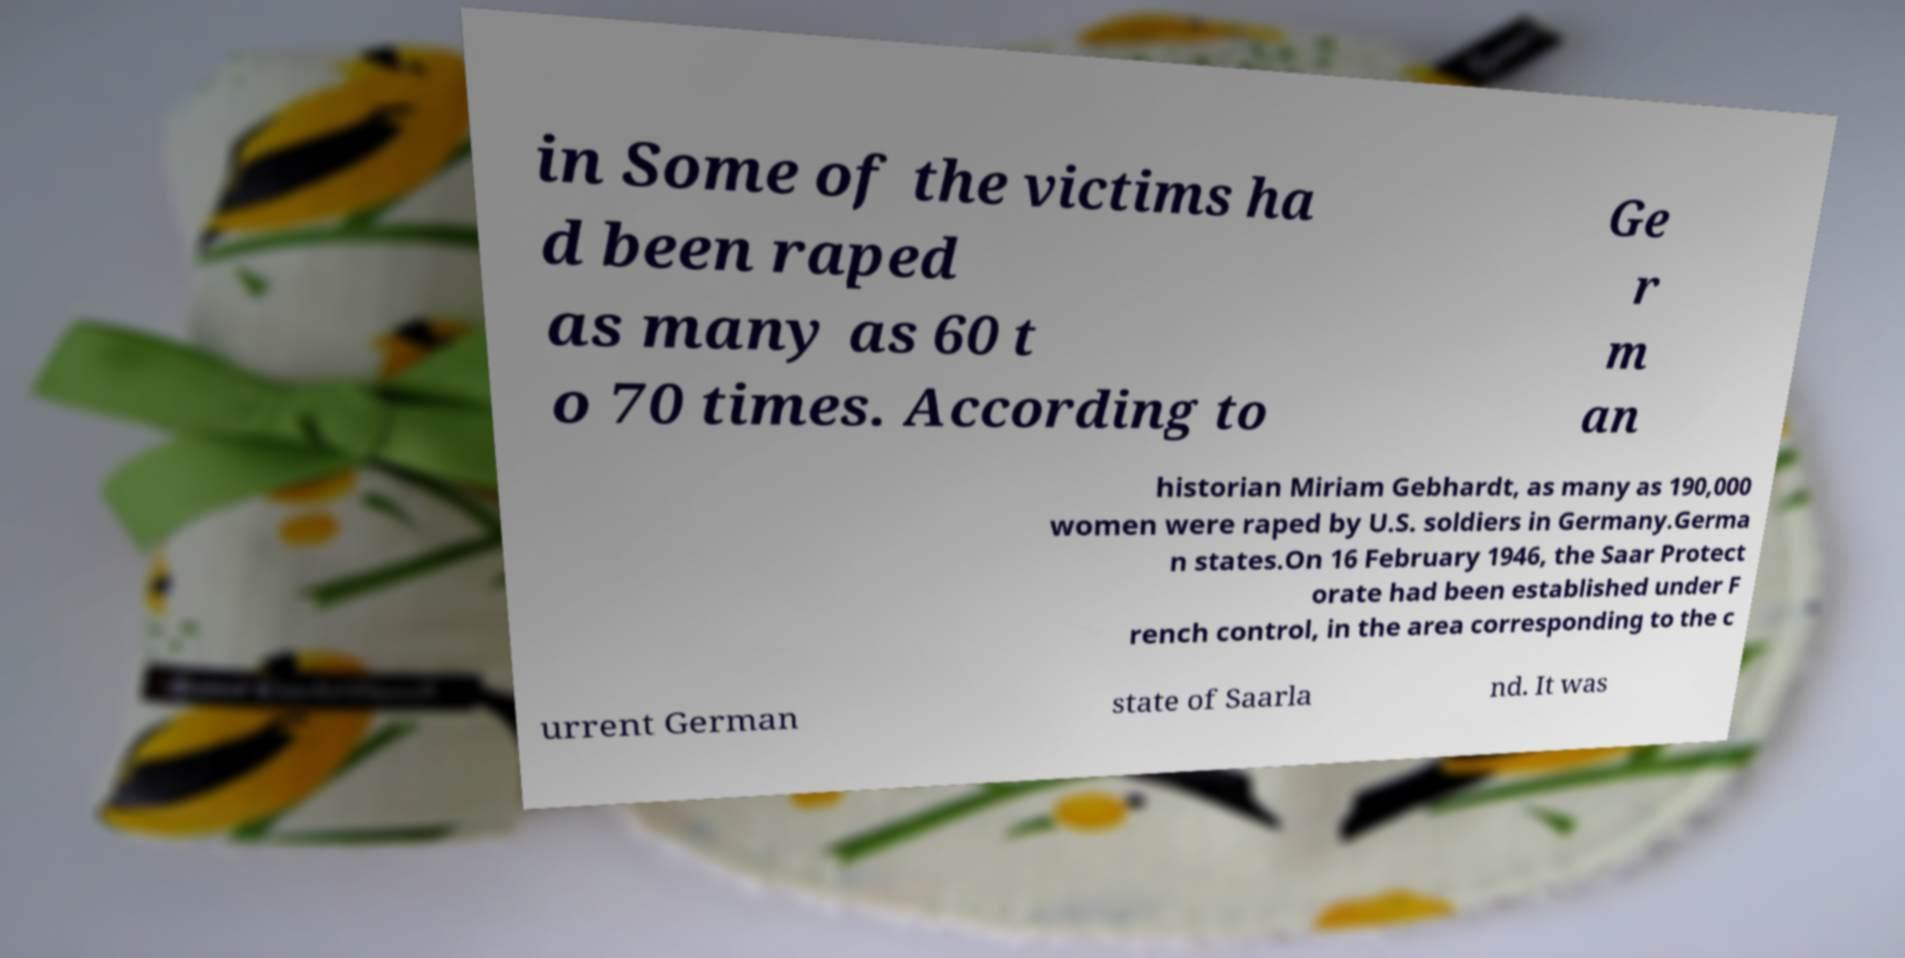I need the written content from this picture converted into text. Can you do that? in Some of the victims ha d been raped as many as 60 t o 70 times. According to Ge r m an historian Miriam Gebhardt, as many as 190,000 women were raped by U.S. soldiers in Germany.Germa n states.On 16 February 1946, the Saar Protect orate had been established under F rench control, in the area corresponding to the c urrent German state of Saarla nd. It was 